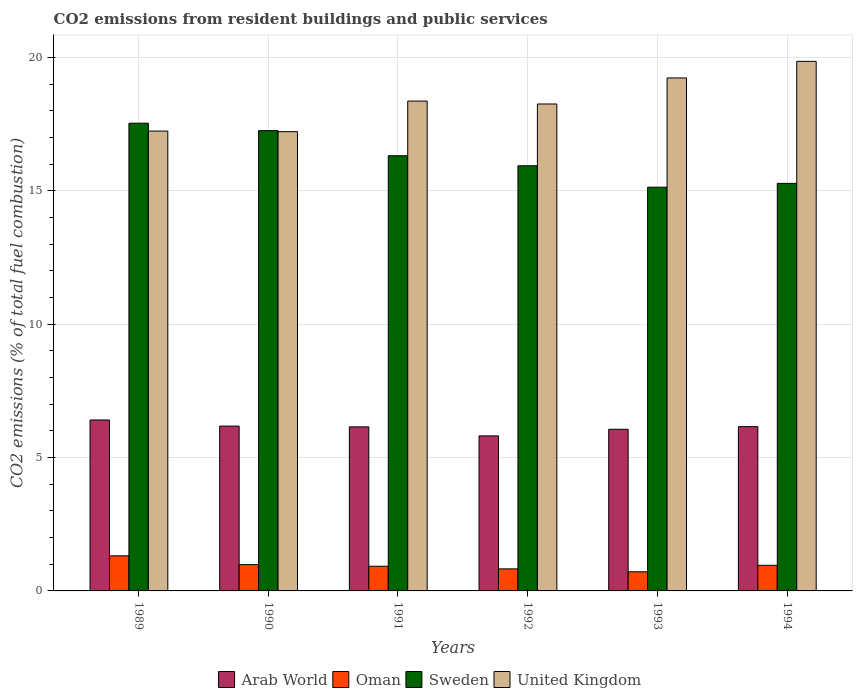Are the number of bars on each tick of the X-axis equal?
Your answer should be very brief. Yes. How many bars are there on the 6th tick from the right?
Give a very brief answer. 4. In how many cases, is the number of bars for a given year not equal to the number of legend labels?
Your response must be concise. 0. What is the total CO2 emitted in Oman in 1989?
Ensure brevity in your answer.  1.32. Across all years, what is the maximum total CO2 emitted in Oman?
Your answer should be very brief. 1.32. Across all years, what is the minimum total CO2 emitted in United Kingdom?
Keep it short and to the point. 17.22. In which year was the total CO2 emitted in Oman maximum?
Ensure brevity in your answer.  1989. What is the total total CO2 emitted in Arab World in the graph?
Your answer should be very brief. 36.77. What is the difference between the total CO2 emitted in Sweden in 1989 and that in 1994?
Make the answer very short. 2.26. What is the difference between the total CO2 emitted in United Kingdom in 1993 and the total CO2 emitted in Sweden in 1989?
Provide a succinct answer. 1.7. What is the average total CO2 emitted in Oman per year?
Your answer should be very brief. 0.96. In the year 1992, what is the difference between the total CO2 emitted in United Kingdom and total CO2 emitted in Oman?
Provide a short and direct response. 17.43. What is the ratio of the total CO2 emitted in Sweden in 1991 to that in 1994?
Offer a terse response. 1.07. Is the total CO2 emitted in Sweden in 1990 less than that in 1992?
Your response must be concise. No. Is the difference between the total CO2 emitted in United Kingdom in 1989 and 1990 greater than the difference between the total CO2 emitted in Oman in 1989 and 1990?
Provide a succinct answer. No. What is the difference between the highest and the second highest total CO2 emitted in Sweden?
Your answer should be compact. 0.28. What is the difference between the highest and the lowest total CO2 emitted in Sweden?
Provide a short and direct response. 2.4. What does the 3rd bar from the left in 1991 represents?
Your response must be concise. Sweden. What does the 4th bar from the right in 1992 represents?
Keep it short and to the point. Arab World. How many years are there in the graph?
Your answer should be compact. 6. What is the difference between two consecutive major ticks on the Y-axis?
Provide a short and direct response. 5. Does the graph contain any zero values?
Provide a succinct answer. No. Does the graph contain grids?
Keep it short and to the point. Yes. Where does the legend appear in the graph?
Offer a very short reply. Bottom center. How many legend labels are there?
Keep it short and to the point. 4. How are the legend labels stacked?
Provide a succinct answer. Horizontal. What is the title of the graph?
Give a very brief answer. CO2 emissions from resident buildings and public services. What is the label or title of the Y-axis?
Offer a terse response. CO2 emissions (% of total fuel combustion). What is the CO2 emissions (% of total fuel combustion) of Arab World in 1989?
Offer a terse response. 6.41. What is the CO2 emissions (% of total fuel combustion) in Oman in 1989?
Offer a terse response. 1.32. What is the CO2 emissions (% of total fuel combustion) of Sweden in 1989?
Your answer should be very brief. 17.54. What is the CO2 emissions (% of total fuel combustion) in United Kingdom in 1989?
Keep it short and to the point. 17.24. What is the CO2 emissions (% of total fuel combustion) of Arab World in 1990?
Your answer should be very brief. 6.18. What is the CO2 emissions (% of total fuel combustion) in Oman in 1990?
Ensure brevity in your answer.  0.99. What is the CO2 emissions (% of total fuel combustion) in Sweden in 1990?
Offer a very short reply. 17.26. What is the CO2 emissions (% of total fuel combustion) in United Kingdom in 1990?
Give a very brief answer. 17.22. What is the CO2 emissions (% of total fuel combustion) of Arab World in 1991?
Offer a very short reply. 6.15. What is the CO2 emissions (% of total fuel combustion) in Oman in 1991?
Your response must be concise. 0.93. What is the CO2 emissions (% of total fuel combustion) in Sweden in 1991?
Your answer should be very brief. 16.32. What is the CO2 emissions (% of total fuel combustion) of United Kingdom in 1991?
Ensure brevity in your answer.  18.36. What is the CO2 emissions (% of total fuel combustion) of Arab World in 1992?
Ensure brevity in your answer.  5.81. What is the CO2 emissions (% of total fuel combustion) in Oman in 1992?
Ensure brevity in your answer.  0.83. What is the CO2 emissions (% of total fuel combustion) in Sweden in 1992?
Offer a very short reply. 15.94. What is the CO2 emissions (% of total fuel combustion) of United Kingdom in 1992?
Provide a short and direct response. 18.26. What is the CO2 emissions (% of total fuel combustion) in Arab World in 1993?
Ensure brevity in your answer.  6.06. What is the CO2 emissions (% of total fuel combustion) of Oman in 1993?
Your response must be concise. 0.72. What is the CO2 emissions (% of total fuel combustion) in Sweden in 1993?
Offer a very short reply. 15.14. What is the CO2 emissions (% of total fuel combustion) in United Kingdom in 1993?
Keep it short and to the point. 19.23. What is the CO2 emissions (% of total fuel combustion) of Arab World in 1994?
Give a very brief answer. 6.16. What is the CO2 emissions (% of total fuel combustion) of Oman in 1994?
Provide a short and direct response. 0.96. What is the CO2 emissions (% of total fuel combustion) of Sweden in 1994?
Keep it short and to the point. 15.28. What is the CO2 emissions (% of total fuel combustion) in United Kingdom in 1994?
Provide a short and direct response. 19.85. Across all years, what is the maximum CO2 emissions (% of total fuel combustion) of Arab World?
Provide a succinct answer. 6.41. Across all years, what is the maximum CO2 emissions (% of total fuel combustion) in Oman?
Provide a short and direct response. 1.32. Across all years, what is the maximum CO2 emissions (% of total fuel combustion) of Sweden?
Ensure brevity in your answer.  17.54. Across all years, what is the maximum CO2 emissions (% of total fuel combustion) in United Kingdom?
Provide a short and direct response. 19.85. Across all years, what is the minimum CO2 emissions (% of total fuel combustion) in Arab World?
Make the answer very short. 5.81. Across all years, what is the minimum CO2 emissions (% of total fuel combustion) in Oman?
Your response must be concise. 0.72. Across all years, what is the minimum CO2 emissions (% of total fuel combustion) of Sweden?
Your answer should be very brief. 15.14. Across all years, what is the minimum CO2 emissions (% of total fuel combustion) of United Kingdom?
Offer a very short reply. 17.22. What is the total CO2 emissions (% of total fuel combustion) of Arab World in the graph?
Make the answer very short. 36.77. What is the total CO2 emissions (% of total fuel combustion) in Oman in the graph?
Provide a succinct answer. 5.73. What is the total CO2 emissions (% of total fuel combustion) of Sweden in the graph?
Keep it short and to the point. 97.46. What is the total CO2 emissions (% of total fuel combustion) in United Kingdom in the graph?
Give a very brief answer. 110.17. What is the difference between the CO2 emissions (% of total fuel combustion) of Arab World in 1989 and that in 1990?
Provide a short and direct response. 0.23. What is the difference between the CO2 emissions (% of total fuel combustion) of Oman in 1989 and that in 1990?
Make the answer very short. 0.33. What is the difference between the CO2 emissions (% of total fuel combustion) of Sweden in 1989 and that in 1990?
Keep it short and to the point. 0.28. What is the difference between the CO2 emissions (% of total fuel combustion) of United Kingdom in 1989 and that in 1990?
Ensure brevity in your answer.  0.02. What is the difference between the CO2 emissions (% of total fuel combustion) of Arab World in 1989 and that in 1991?
Your answer should be compact. 0.26. What is the difference between the CO2 emissions (% of total fuel combustion) in Oman in 1989 and that in 1991?
Give a very brief answer. 0.39. What is the difference between the CO2 emissions (% of total fuel combustion) of Sweden in 1989 and that in 1991?
Keep it short and to the point. 1.22. What is the difference between the CO2 emissions (% of total fuel combustion) in United Kingdom in 1989 and that in 1991?
Give a very brief answer. -1.12. What is the difference between the CO2 emissions (% of total fuel combustion) in Arab World in 1989 and that in 1992?
Your response must be concise. 0.6. What is the difference between the CO2 emissions (% of total fuel combustion) of Oman in 1989 and that in 1992?
Keep it short and to the point. 0.49. What is the difference between the CO2 emissions (% of total fuel combustion) of Sweden in 1989 and that in 1992?
Provide a short and direct response. 1.6. What is the difference between the CO2 emissions (% of total fuel combustion) of United Kingdom in 1989 and that in 1992?
Offer a very short reply. -1.02. What is the difference between the CO2 emissions (% of total fuel combustion) of Arab World in 1989 and that in 1993?
Provide a short and direct response. 0.35. What is the difference between the CO2 emissions (% of total fuel combustion) in Oman in 1989 and that in 1993?
Offer a terse response. 0.6. What is the difference between the CO2 emissions (% of total fuel combustion) in Sweden in 1989 and that in 1993?
Provide a short and direct response. 2.4. What is the difference between the CO2 emissions (% of total fuel combustion) of United Kingdom in 1989 and that in 1993?
Offer a terse response. -1.99. What is the difference between the CO2 emissions (% of total fuel combustion) in Arab World in 1989 and that in 1994?
Ensure brevity in your answer.  0.25. What is the difference between the CO2 emissions (% of total fuel combustion) of Oman in 1989 and that in 1994?
Your answer should be very brief. 0.35. What is the difference between the CO2 emissions (% of total fuel combustion) in Sweden in 1989 and that in 1994?
Keep it short and to the point. 2.26. What is the difference between the CO2 emissions (% of total fuel combustion) in United Kingdom in 1989 and that in 1994?
Offer a very short reply. -2.61. What is the difference between the CO2 emissions (% of total fuel combustion) of Arab World in 1990 and that in 1991?
Your response must be concise. 0.03. What is the difference between the CO2 emissions (% of total fuel combustion) of Oman in 1990 and that in 1991?
Your answer should be very brief. 0.06. What is the difference between the CO2 emissions (% of total fuel combustion) in Sweden in 1990 and that in 1991?
Make the answer very short. 0.94. What is the difference between the CO2 emissions (% of total fuel combustion) of United Kingdom in 1990 and that in 1991?
Your answer should be very brief. -1.15. What is the difference between the CO2 emissions (% of total fuel combustion) of Arab World in 1990 and that in 1992?
Your response must be concise. 0.37. What is the difference between the CO2 emissions (% of total fuel combustion) in Oman in 1990 and that in 1992?
Make the answer very short. 0.16. What is the difference between the CO2 emissions (% of total fuel combustion) in Sweden in 1990 and that in 1992?
Your answer should be very brief. 1.32. What is the difference between the CO2 emissions (% of total fuel combustion) of United Kingdom in 1990 and that in 1992?
Offer a terse response. -1.04. What is the difference between the CO2 emissions (% of total fuel combustion) in Arab World in 1990 and that in 1993?
Your answer should be compact. 0.12. What is the difference between the CO2 emissions (% of total fuel combustion) of Oman in 1990 and that in 1993?
Offer a terse response. 0.27. What is the difference between the CO2 emissions (% of total fuel combustion) in Sweden in 1990 and that in 1993?
Your answer should be very brief. 2.12. What is the difference between the CO2 emissions (% of total fuel combustion) of United Kingdom in 1990 and that in 1993?
Your answer should be very brief. -2.01. What is the difference between the CO2 emissions (% of total fuel combustion) of Arab World in 1990 and that in 1994?
Make the answer very short. 0.02. What is the difference between the CO2 emissions (% of total fuel combustion) in Oman in 1990 and that in 1994?
Your answer should be compact. 0.03. What is the difference between the CO2 emissions (% of total fuel combustion) of Sweden in 1990 and that in 1994?
Ensure brevity in your answer.  1.98. What is the difference between the CO2 emissions (% of total fuel combustion) in United Kingdom in 1990 and that in 1994?
Give a very brief answer. -2.64. What is the difference between the CO2 emissions (% of total fuel combustion) in Arab World in 1991 and that in 1992?
Your response must be concise. 0.34. What is the difference between the CO2 emissions (% of total fuel combustion) of Oman in 1991 and that in 1992?
Give a very brief answer. 0.1. What is the difference between the CO2 emissions (% of total fuel combustion) in Sweden in 1991 and that in 1992?
Offer a terse response. 0.38. What is the difference between the CO2 emissions (% of total fuel combustion) of United Kingdom in 1991 and that in 1992?
Offer a terse response. 0.11. What is the difference between the CO2 emissions (% of total fuel combustion) in Arab World in 1991 and that in 1993?
Your response must be concise. 0.09. What is the difference between the CO2 emissions (% of total fuel combustion) of Oman in 1991 and that in 1993?
Offer a terse response. 0.21. What is the difference between the CO2 emissions (% of total fuel combustion) of Sweden in 1991 and that in 1993?
Keep it short and to the point. 1.18. What is the difference between the CO2 emissions (% of total fuel combustion) of United Kingdom in 1991 and that in 1993?
Make the answer very short. -0.87. What is the difference between the CO2 emissions (% of total fuel combustion) in Arab World in 1991 and that in 1994?
Ensure brevity in your answer.  -0.01. What is the difference between the CO2 emissions (% of total fuel combustion) in Oman in 1991 and that in 1994?
Offer a very short reply. -0.04. What is the difference between the CO2 emissions (% of total fuel combustion) in Sweden in 1991 and that in 1994?
Your answer should be compact. 1.04. What is the difference between the CO2 emissions (% of total fuel combustion) in United Kingdom in 1991 and that in 1994?
Offer a very short reply. -1.49. What is the difference between the CO2 emissions (% of total fuel combustion) of Arab World in 1992 and that in 1993?
Your response must be concise. -0.25. What is the difference between the CO2 emissions (% of total fuel combustion) in Oman in 1992 and that in 1993?
Give a very brief answer. 0.11. What is the difference between the CO2 emissions (% of total fuel combustion) of Sweden in 1992 and that in 1993?
Keep it short and to the point. 0.8. What is the difference between the CO2 emissions (% of total fuel combustion) in United Kingdom in 1992 and that in 1993?
Provide a succinct answer. -0.98. What is the difference between the CO2 emissions (% of total fuel combustion) in Arab World in 1992 and that in 1994?
Make the answer very short. -0.35. What is the difference between the CO2 emissions (% of total fuel combustion) of Oman in 1992 and that in 1994?
Make the answer very short. -0.13. What is the difference between the CO2 emissions (% of total fuel combustion) in Sweden in 1992 and that in 1994?
Make the answer very short. 0.66. What is the difference between the CO2 emissions (% of total fuel combustion) in United Kingdom in 1992 and that in 1994?
Provide a short and direct response. -1.6. What is the difference between the CO2 emissions (% of total fuel combustion) of Arab World in 1993 and that in 1994?
Keep it short and to the point. -0.1. What is the difference between the CO2 emissions (% of total fuel combustion) in Oman in 1993 and that in 1994?
Keep it short and to the point. -0.24. What is the difference between the CO2 emissions (% of total fuel combustion) of Sweden in 1993 and that in 1994?
Your response must be concise. -0.14. What is the difference between the CO2 emissions (% of total fuel combustion) in United Kingdom in 1993 and that in 1994?
Provide a short and direct response. -0.62. What is the difference between the CO2 emissions (% of total fuel combustion) of Arab World in 1989 and the CO2 emissions (% of total fuel combustion) of Oman in 1990?
Your response must be concise. 5.42. What is the difference between the CO2 emissions (% of total fuel combustion) in Arab World in 1989 and the CO2 emissions (% of total fuel combustion) in Sweden in 1990?
Provide a succinct answer. -10.85. What is the difference between the CO2 emissions (% of total fuel combustion) of Arab World in 1989 and the CO2 emissions (% of total fuel combustion) of United Kingdom in 1990?
Offer a very short reply. -10.81. What is the difference between the CO2 emissions (% of total fuel combustion) of Oman in 1989 and the CO2 emissions (% of total fuel combustion) of Sweden in 1990?
Offer a very short reply. -15.94. What is the difference between the CO2 emissions (% of total fuel combustion) in Oman in 1989 and the CO2 emissions (% of total fuel combustion) in United Kingdom in 1990?
Make the answer very short. -15.9. What is the difference between the CO2 emissions (% of total fuel combustion) of Sweden in 1989 and the CO2 emissions (% of total fuel combustion) of United Kingdom in 1990?
Your answer should be very brief. 0.32. What is the difference between the CO2 emissions (% of total fuel combustion) of Arab World in 1989 and the CO2 emissions (% of total fuel combustion) of Oman in 1991?
Offer a very short reply. 5.48. What is the difference between the CO2 emissions (% of total fuel combustion) of Arab World in 1989 and the CO2 emissions (% of total fuel combustion) of Sweden in 1991?
Your answer should be compact. -9.91. What is the difference between the CO2 emissions (% of total fuel combustion) of Arab World in 1989 and the CO2 emissions (% of total fuel combustion) of United Kingdom in 1991?
Give a very brief answer. -11.96. What is the difference between the CO2 emissions (% of total fuel combustion) of Oman in 1989 and the CO2 emissions (% of total fuel combustion) of Sweden in 1991?
Your answer should be very brief. -15. What is the difference between the CO2 emissions (% of total fuel combustion) in Oman in 1989 and the CO2 emissions (% of total fuel combustion) in United Kingdom in 1991?
Provide a short and direct response. -17.05. What is the difference between the CO2 emissions (% of total fuel combustion) in Sweden in 1989 and the CO2 emissions (% of total fuel combustion) in United Kingdom in 1991?
Ensure brevity in your answer.  -0.83. What is the difference between the CO2 emissions (% of total fuel combustion) in Arab World in 1989 and the CO2 emissions (% of total fuel combustion) in Oman in 1992?
Offer a very short reply. 5.58. What is the difference between the CO2 emissions (% of total fuel combustion) of Arab World in 1989 and the CO2 emissions (% of total fuel combustion) of Sweden in 1992?
Keep it short and to the point. -9.53. What is the difference between the CO2 emissions (% of total fuel combustion) in Arab World in 1989 and the CO2 emissions (% of total fuel combustion) in United Kingdom in 1992?
Provide a short and direct response. -11.85. What is the difference between the CO2 emissions (% of total fuel combustion) of Oman in 1989 and the CO2 emissions (% of total fuel combustion) of Sweden in 1992?
Your answer should be compact. -14.62. What is the difference between the CO2 emissions (% of total fuel combustion) in Oman in 1989 and the CO2 emissions (% of total fuel combustion) in United Kingdom in 1992?
Offer a very short reply. -16.94. What is the difference between the CO2 emissions (% of total fuel combustion) of Sweden in 1989 and the CO2 emissions (% of total fuel combustion) of United Kingdom in 1992?
Provide a short and direct response. -0.72. What is the difference between the CO2 emissions (% of total fuel combustion) of Arab World in 1989 and the CO2 emissions (% of total fuel combustion) of Oman in 1993?
Offer a terse response. 5.69. What is the difference between the CO2 emissions (% of total fuel combustion) of Arab World in 1989 and the CO2 emissions (% of total fuel combustion) of Sweden in 1993?
Your response must be concise. -8.73. What is the difference between the CO2 emissions (% of total fuel combustion) in Arab World in 1989 and the CO2 emissions (% of total fuel combustion) in United Kingdom in 1993?
Provide a succinct answer. -12.82. What is the difference between the CO2 emissions (% of total fuel combustion) in Oman in 1989 and the CO2 emissions (% of total fuel combustion) in Sweden in 1993?
Give a very brief answer. -13.82. What is the difference between the CO2 emissions (% of total fuel combustion) in Oman in 1989 and the CO2 emissions (% of total fuel combustion) in United Kingdom in 1993?
Offer a terse response. -17.92. What is the difference between the CO2 emissions (% of total fuel combustion) of Sweden in 1989 and the CO2 emissions (% of total fuel combustion) of United Kingdom in 1993?
Provide a succinct answer. -1.7. What is the difference between the CO2 emissions (% of total fuel combustion) in Arab World in 1989 and the CO2 emissions (% of total fuel combustion) in Oman in 1994?
Your answer should be very brief. 5.45. What is the difference between the CO2 emissions (% of total fuel combustion) in Arab World in 1989 and the CO2 emissions (% of total fuel combustion) in Sweden in 1994?
Your answer should be compact. -8.87. What is the difference between the CO2 emissions (% of total fuel combustion) in Arab World in 1989 and the CO2 emissions (% of total fuel combustion) in United Kingdom in 1994?
Your answer should be compact. -13.45. What is the difference between the CO2 emissions (% of total fuel combustion) of Oman in 1989 and the CO2 emissions (% of total fuel combustion) of Sweden in 1994?
Make the answer very short. -13.96. What is the difference between the CO2 emissions (% of total fuel combustion) of Oman in 1989 and the CO2 emissions (% of total fuel combustion) of United Kingdom in 1994?
Make the answer very short. -18.54. What is the difference between the CO2 emissions (% of total fuel combustion) of Sweden in 1989 and the CO2 emissions (% of total fuel combustion) of United Kingdom in 1994?
Your response must be concise. -2.32. What is the difference between the CO2 emissions (% of total fuel combustion) in Arab World in 1990 and the CO2 emissions (% of total fuel combustion) in Oman in 1991?
Ensure brevity in your answer.  5.25. What is the difference between the CO2 emissions (% of total fuel combustion) of Arab World in 1990 and the CO2 emissions (% of total fuel combustion) of Sweden in 1991?
Your answer should be compact. -10.14. What is the difference between the CO2 emissions (% of total fuel combustion) of Arab World in 1990 and the CO2 emissions (% of total fuel combustion) of United Kingdom in 1991?
Provide a short and direct response. -12.19. What is the difference between the CO2 emissions (% of total fuel combustion) in Oman in 1990 and the CO2 emissions (% of total fuel combustion) in Sweden in 1991?
Provide a short and direct response. -15.33. What is the difference between the CO2 emissions (% of total fuel combustion) in Oman in 1990 and the CO2 emissions (% of total fuel combustion) in United Kingdom in 1991?
Your answer should be very brief. -17.38. What is the difference between the CO2 emissions (% of total fuel combustion) in Sweden in 1990 and the CO2 emissions (% of total fuel combustion) in United Kingdom in 1991?
Provide a succinct answer. -1.11. What is the difference between the CO2 emissions (% of total fuel combustion) of Arab World in 1990 and the CO2 emissions (% of total fuel combustion) of Oman in 1992?
Offer a terse response. 5.35. What is the difference between the CO2 emissions (% of total fuel combustion) in Arab World in 1990 and the CO2 emissions (% of total fuel combustion) in Sweden in 1992?
Make the answer very short. -9.76. What is the difference between the CO2 emissions (% of total fuel combustion) in Arab World in 1990 and the CO2 emissions (% of total fuel combustion) in United Kingdom in 1992?
Your answer should be very brief. -12.08. What is the difference between the CO2 emissions (% of total fuel combustion) of Oman in 1990 and the CO2 emissions (% of total fuel combustion) of Sweden in 1992?
Your response must be concise. -14.95. What is the difference between the CO2 emissions (% of total fuel combustion) in Oman in 1990 and the CO2 emissions (% of total fuel combustion) in United Kingdom in 1992?
Offer a terse response. -17.27. What is the difference between the CO2 emissions (% of total fuel combustion) of Sweden in 1990 and the CO2 emissions (% of total fuel combustion) of United Kingdom in 1992?
Make the answer very short. -1. What is the difference between the CO2 emissions (% of total fuel combustion) in Arab World in 1990 and the CO2 emissions (% of total fuel combustion) in Oman in 1993?
Provide a short and direct response. 5.46. What is the difference between the CO2 emissions (% of total fuel combustion) of Arab World in 1990 and the CO2 emissions (% of total fuel combustion) of Sweden in 1993?
Provide a short and direct response. -8.96. What is the difference between the CO2 emissions (% of total fuel combustion) of Arab World in 1990 and the CO2 emissions (% of total fuel combustion) of United Kingdom in 1993?
Ensure brevity in your answer.  -13.05. What is the difference between the CO2 emissions (% of total fuel combustion) in Oman in 1990 and the CO2 emissions (% of total fuel combustion) in Sweden in 1993?
Offer a terse response. -14.15. What is the difference between the CO2 emissions (% of total fuel combustion) in Oman in 1990 and the CO2 emissions (% of total fuel combustion) in United Kingdom in 1993?
Give a very brief answer. -18.25. What is the difference between the CO2 emissions (% of total fuel combustion) in Sweden in 1990 and the CO2 emissions (% of total fuel combustion) in United Kingdom in 1993?
Your response must be concise. -1.98. What is the difference between the CO2 emissions (% of total fuel combustion) of Arab World in 1990 and the CO2 emissions (% of total fuel combustion) of Oman in 1994?
Offer a very short reply. 5.22. What is the difference between the CO2 emissions (% of total fuel combustion) of Arab World in 1990 and the CO2 emissions (% of total fuel combustion) of Sweden in 1994?
Keep it short and to the point. -9.1. What is the difference between the CO2 emissions (% of total fuel combustion) of Arab World in 1990 and the CO2 emissions (% of total fuel combustion) of United Kingdom in 1994?
Your answer should be very brief. -13.68. What is the difference between the CO2 emissions (% of total fuel combustion) in Oman in 1990 and the CO2 emissions (% of total fuel combustion) in Sweden in 1994?
Give a very brief answer. -14.29. What is the difference between the CO2 emissions (% of total fuel combustion) of Oman in 1990 and the CO2 emissions (% of total fuel combustion) of United Kingdom in 1994?
Provide a short and direct response. -18.87. What is the difference between the CO2 emissions (% of total fuel combustion) of Sweden in 1990 and the CO2 emissions (% of total fuel combustion) of United Kingdom in 1994?
Keep it short and to the point. -2.6. What is the difference between the CO2 emissions (% of total fuel combustion) in Arab World in 1991 and the CO2 emissions (% of total fuel combustion) in Oman in 1992?
Make the answer very short. 5.32. What is the difference between the CO2 emissions (% of total fuel combustion) in Arab World in 1991 and the CO2 emissions (% of total fuel combustion) in Sweden in 1992?
Make the answer very short. -9.79. What is the difference between the CO2 emissions (% of total fuel combustion) in Arab World in 1991 and the CO2 emissions (% of total fuel combustion) in United Kingdom in 1992?
Provide a short and direct response. -12.11. What is the difference between the CO2 emissions (% of total fuel combustion) in Oman in 1991 and the CO2 emissions (% of total fuel combustion) in Sweden in 1992?
Provide a succinct answer. -15.01. What is the difference between the CO2 emissions (% of total fuel combustion) of Oman in 1991 and the CO2 emissions (% of total fuel combustion) of United Kingdom in 1992?
Give a very brief answer. -17.33. What is the difference between the CO2 emissions (% of total fuel combustion) of Sweden in 1991 and the CO2 emissions (% of total fuel combustion) of United Kingdom in 1992?
Give a very brief answer. -1.94. What is the difference between the CO2 emissions (% of total fuel combustion) in Arab World in 1991 and the CO2 emissions (% of total fuel combustion) in Oman in 1993?
Your answer should be very brief. 5.43. What is the difference between the CO2 emissions (% of total fuel combustion) of Arab World in 1991 and the CO2 emissions (% of total fuel combustion) of Sweden in 1993?
Offer a terse response. -8.99. What is the difference between the CO2 emissions (% of total fuel combustion) of Arab World in 1991 and the CO2 emissions (% of total fuel combustion) of United Kingdom in 1993?
Give a very brief answer. -13.08. What is the difference between the CO2 emissions (% of total fuel combustion) in Oman in 1991 and the CO2 emissions (% of total fuel combustion) in Sweden in 1993?
Make the answer very short. -14.21. What is the difference between the CO2 emissions (% of total fuel combustion) in Oman in 1991 and the CO2 emissions (% of total fuel combustion) in United Kingdom in 1993?
Provide a succinct answer. -18.31. What is the difference between the CO2 emissions (% of total fuel combustion) of Sweden in 1991 and the CO2 emissions (% of total fuel combustion) of United Kingdom in 1993?
Make the answer very short. -2.92. What is the difference between the CO2 emissions (% of total fuel combustion) of Arab World in 1991 and the CO2 emissions (% of total fuel combustion) of Oman in 1994?
Give a very brief answer. 5.19. What is the difference between the CO2 emissions (% of total fuel combustion) of Arab World in 1991 and the CO2 emissions (% of total fuel combustion) of Sweden in 1994?
Your answer should be very brief. -9.13. What is the difference between the CO2 emissions (% of total fuel combustion) in Arab World in 1991 and the CO2 emissions (% of total fuel combustion) in United Kingdom in 1994?
Your answer should be very brief. -13.7. What is the difference between the CO2 emissions (% of total fuel combustion) of Oman in 1991 and the CO2 emissions (% of total fuel combustion) of Sweden in 1994?
Provide a succinct answer. -14.35. What is the difference between the CO2 emissions (% of total fuel combustion) of Oman in 1991 and the CO2 emissions (% of total fuel combustion) of United Kingdom in 1994?
Give a very brief answer. -18.93. What is the difference between the CO2 emissions (% of total fuel combustion) of Sweden in 1991 and the CO2 emissions (% of total fuel combustion) of United Kingdom in 1994?
Ensure brevity in your answer.  -3.54. What is the difference between the CO2 emissions (% of total fuel combustion) in Arab World in 1992 and the CO2 emissions (% of total fuel combustion) in Oman in 1993?
Provide a succinct answer. 5.1. What is the difference between the CO2 emissions (% of total fuel combustion) of Arab World in 1992 and the CO2 emissions (% of total fuel combustion) of Sweden in 1993?
Give a very brief answer. -9.32. What is the difference between the CO2 emissions (% of total fuel combustion) in Arab World in 1992 and the CO2 emissions (% of total fuel combustion) in United Kingdom in 1993?
Offer a terse response. -13.42. What is the difference between the CO2 emissions (% of total fuel combustion) in Oman in 1992 and the CO2 emissions (% of total fuel combustion) in Sweden in 1993?
Provide a short and direct response. -14.31. What is the difference between the CO2 emissions (% of total fuel combustion) in Oman in 1992 and the CO2 emissions (% of total fuel combustion) in United Kingdom in 1993?
Offer a terse response. -18.41. What is the difference between the CO2 emissions (% of total fuel combustion) in Sweden in 1992 and the CO2 emissions (% of total fuel combustion) in United Kingdom in 1993?
Give a very brief answer. -3.29. What is the difference between the CO2 emissions (% of total fuel combustion) of Arab World in 1992 and the CO2 emissions (% of total fuel combustion) of Oman in 1994?
Give a very brief answer. 4.85. What is the difference between the CO2 emissions (% of total fuel combustion) of Arab World in 1992 and the CO2 emissions (% of total fuel combustion) of Sweden in 1994?
Keep it short and to the point. -9.47. What is the difference between the CO2 emissions (% of total fuel combustion) of Arab World in 1992 and the CO2 emissions (% of total fuel combustion) of United Kingdom in 1994?
Make the answer very short. -14.04. What is the difference between the CO2 emissions (% of total fuel combustion) in Oman in 1992 and the CO2 emissions (% of total fuel combustion) in Sweden in 1994?
Your answer should be very brief. -14.45. What is the difference between the CO2 emissions (% of total fuel combustion) in Oman in 1992 and the CO2 emissions (% of total fuel combustion) in United Kingdom in 1994?
Your answer should be compact. -19.03. What is the difference between the CO2 emissions (% of total fuel combustion) of Sweden in 1992 and the CO2 emissions (% of total fuel combustion) of United Kingdom in 1994?
Offer a very short reply. -3.91. What is the difference between the CO2 emissions (% of total fuel combustion) of Arab World in 1993 and the CO2 emissions (% of total fuel combustion) of Oman in 1994?
Keep it short and to the point. 5.1. What is the difference between the CO2 emissions (% of total fuel combustion) in Arab World in 1993 and the CO2 emissions (% of total fuel combustion) in Sweden in 1994?
Give a very brief answer. -9.22. What is the difference between the CO2 emissions (% of total fuel combustion) in Arab World in 1993 and the CO2 emissions (% of total fuel combustion) in United Kingdom in 1994?
Keep it short and to the point. -13.79. What is the difference between the CO2 emissions (% of total fuel combustion) of Oman in 1993 and the CO2 emissions (% of total fuel combustion) of Sweden in 1994?
Ensure brevity in your answer.  -14.56. What is the difference between the CO2 emissions (% of total fuel combustion) of Oman in 1993 and the CO2 emissions (% of total fuel combustion) of United Kingdom in 1994?
Your answer should be compact. -19.14. What is the difference between the CO2 emissions (% of total fuel combustion) of Sweden in 1993 and the CO2 emissions (% of total fuel combustion) of United Kingdom in 1994?
Make the answer very short. -4.72. What is the average CO2 emissions (% of total fuel combustion) of Arab World per year?
Give a very brief answer. 6.13. What is the average CO2 emissions (% of total fuel combustion) in Oman per year?
Offer a very short reply. 0.96. What is the average CO2 emissions (% of total fuel combustion) of Sweden per year?
Keep it short and to the point. 16.24. What is the average CO2 emissions (% of total fuel combustion) of United Kingdom per year?
Your answer should be compact. 18.36. In the year 1989, what is the difference between the CO2 emissions (% of total fuel combustion) of Arab World and CO2 emissions (% of total fuel combustion) of Oman?
Your answer should be very brief. 5.09. In the year 1989, what is the difference between the CO2 emissions (% of total fuel combustion) of Arab World and CO2 emissions (% of total fuel combustion) of Sweden?
Ensure brevity in your answer.  -11.13. In the year 1989, what is the difference between the CO2 emissions (% of total fuel combustion) of Arab World and CO2 emissions (% of total fuel combustion) of United Kingdom?
Your answer should be very brief. -10.83. In the year 1989, what is the difference between the CO2 emissions (% of total fuel combustion) of Oman and CO2 emissions (% of total fuel combustion) of Sweden?
Ensure brevity in your answer.  -16.22. In the year 1989, what is the difference between the CO2 emissions (% of total fuel combustion) in Oman and CO2 emissions (% of total fuel combustion) in United Kingdom?
Your answer should be compact. -15.92. In the year 1989, what is the difference between the CO2 emissions (% of total fuel combustion) in Sweden and CO2 emissions (% of total fuel combustion) in United Kingdom?
Ensure brevity in your answer.  0.3. In the year 1990, what is the difference between the CO2 emissions (% of total fuel combustion) of Arab World and CO2 emissions (% of total fuel combustion) of Oman?
Make the answer very short. 5.19. In the year 1990, what is the difference between the CO2 emissions (% of total fuel combustion) in Arab World and CO2 emissions (% of total fuel combustion) in Sweden?
Your response must be concise. -11.08. In the year 1990, what is the difference between the CO2 emissions (% of total fuel combustion) of Arab World and CO2 emissions (% of total fuel combustion) of United Kingdom?
Provide a short and direct response. -11.04. In the year 1990, what is the difference between the CO2 emissions (% of total fuel combustion) in Oman and CO2 emissions (% of total fuel combustion) in Sweden?
Keep it short and to the point. -16.27. In the year 1990, what is the difference between the CO2 emissions (% of total fuel combustion) in Oman and CO2 emissions (% of total fuel combustion) in United Kingdom?
Keep it short and to the point. -16.23. In the year 1990, what is the difference between the CO2 emissions (% of total fuel combustion) in Sweden and CO2 emissions (% of total fuel combustion) in United Kingdom?
Provide a succinct answer. 0.04. In the year 1991, what is the difference between the CO2 emissions (% of total fuel combustion) in Arab World and CO2 emissions (% of total fuel combustion) in Oman?
Keep it short and to the point. 5.23. In the year 1991, what is the difference between the CO2 emissions (% of total fuel combustion) in Arab World and CO2 emissions (% of total fuel combustion) in Sweden?
Offer a terse response. -10.16. In the year 1991, what is the difference between the CO2 emissions (% of total fuel combustion) in Arab World and CO2 emissions (% of total fuel combustion) in United Kingdom?
Your answer should be compact. -12.21. In the year 1991, what is the difference between the CO2 emissions (% of total fuel combustion) in Oman and CO2 emissions (% of total fuel combustion) in Sweden?
Ensure brevity in your answer.  -15.39. In the year 1991, what is the difference between the CO2 emissions (% of total fuel combustion) in Oman and CO2 emissions (% of total fuel combustion) in United Kingdom?
Provide a short and direct response. -17.44. In the year 1991, what is the difference between the CO2 emissions (% of total fuel combustion) of Sweden and CO2 emissions (% of total fuel combustion) of United Kingdom?
Provide a short and direct response. -2.05. In the year 1992, what is the difference between the CO2 emissions (% of total fuel combustion) of Arab World and CO2 emissions (% of total fuel combustion) of Oman?
Your answer should be compact. 4.99. In the year 1992, what is the difference between the CO2 emissions (% of total fuel combustion) in Arab World and CO2 emissions (% of total fuel combustion) in Sweden?
Your answer should be very brief. -10.13. In the year 1992, what is the difference between the CO2 emissions (% of total fuel combustion) in Arab World and CO2 emissions (% of total fuel combustion) in United Kingdom?
Keep it short and to the point. -12.44. In the year 1992, what is the difference between the CO2 emissions (% of total fuel combustion) in Oman and CO2 emissions (% of total fuel combustion) in Sweden?
Keep it short and to the point. -15.11. In the year 1992, what is the difference between the CO2 emissions (% of total fuel combustion) of Oman and CO2 emissions (% of total fuel combustion) of United Kingdom?
Provide a short and direct response. -17.43. In the year 1992, what is the difference between the CO2 emissions (% of total fuel combustion) in Sweden and CO2 emissions (% of total fuel combustion) in United Kingdom?
Your answer should be very brief. -2.32. In the year 1993, what is the difference between the CO2 emissions (% of total fuel combustion) in Arab World and CO2 emissions (% of total fuel combustion) in Oman?
Provide a short and direct response. 5.34. In the year 1993, what is the difference between the CO2 emissions (% of total fuel combustion) of Arab World and CO2 emissions (% of total fuel combustion) of Sweden?
Keep it short and to the point. -9.08. In the year 1993, what is the difference between the CO2 emissions (% of total fuel combustion) in Arab World and CO2 emissions (% of total fuel combustion) in United Kingdom?
Provide a succinct answer. -13.17. In the year 1993, what is the difference between the CO2 emissions (% of total fuel combustion) of Oman and CO2 emissions (% of total fuel combustion) of Sweden?
Make the answer very short. -14.42. In the year 1993, what is the difference between the CO2 emissions (% of total fuel combustion) in Oman and CO2 emissions (% of total fuel combustion) in United Kingdom?
Make the answer very short. -18.51. In the year 1993, what is the difference between the CO2 emissions (% of total fuel combustion) of Sweden and CO2 emissions (% of total fuel combustion) of United Kingdom?
Make the answer very short. -4.1. In the year 1994, what is the difference between the CO2 emissions (% of total fuel combustion) in Arab World and CO2 emissions (% of total fuel combustion) in Oman?
Offer a very short reply. 5.2. In the year 1994, what is the difference between the CO2 emissions (% of total fuel combustion) of Arab World and CO2 emissions (% of total fuel combustion) of Sweden?
Provide a short and direct response. -9.12. In the year 1994, what is the difference between the CO2 emissions (% of total fuel combustion) of Arab World and CO2 emissions (% of total fuel combustion) of United Kingdom?
Provide a succinct answer. -13.69. In the year 1994, what is the difference between the CO2 emissions (% of total fuel combustion) in Oman and CO2 emissions (% of total fuel combustion) in Sweden?
Your answer should be compact. -14.32. In the year 1994, what is the difference between the CO2 emissions (% of total fuel combustion) in Oman and CO2 emissions (% of total fuel combustion) in United Kingdom?
Keep it short and to the point. -18.89. In the year 1994, what is the difference between the CO2 emissions (% of total fuel combustion) of Sweden and CO2 emissions (% of total fuel combustion) of United Kingdom?
Give a very brief answer. -4.57. What is the ratio of the CO2 emissions (% of total fuel combustion) in Arab World in 1989 to that in 1990?
Your response must be concise. 1.04. What is the ratio of the CO2 emissions (% of total fuel combustion) in Oman in 1989 to that in 1990?
Your answer should be very brief. 1.33. What is the ratio of the CO2 emissions (% of total fuel combustion) in Sweden in 1989 to that in 1990?
Your answer should be compact. 1.02. What is the ratio of the CO2 emissions (% of total fuel combustion) in United Kingdom in 1989 to that in 1990?
Your response must be concise. 1. What is the ratio of the CO2 emissions (% of total fuel combustion) in Arab World in 1989 to that in 1991?
Provide a short and direct response. 1.04. What is the ratio of the CO2 emissions (% of total fuel combustion) of Oman in 1989 to that in 1991?
Keep it short and to the point. 1.42. What is the ratio of the CO2 emissions (% of total fuel combustion) in Sweden in 1989 to that in 1991?
Offer a very short reply. 1.07. What is the ratio of the CO2 emissions (% of total fuel combustion) of United Kingdom in 1989 to that in 1991?
Keep it short and to the point. 0.94. What is the ratio of the CO2 emissions (% of total fuel combustion) in Arab World in 1989 to that in 1992?
Give a very brief answer. 1.1. What is the ratio of the CO2 emissions (% of total fuel combustion) of Oman in 1989 to that in 1992?
Offer a terse response. 1.59. What is the ratio of the CO2 emissions (% of total fuel combustion) of Sweden in 1989 to that in 1992?
Your answer should be compact. 1.1. What is the ratio of the CO2 emissions (% of total fuel combustion) of Arab World in 1989 to that in 1993?
Keep it short and to the point. 1.06. What is the ratio of the CO2 emissions (% of total fuel combustion) in Oman in 1989 to that in 1993?
Make the answer very short. 1.83. What is the ratio of the CO2 emissions (% of total fuel combustion) of Sweden in 1989 to that in 1993?
Provide a succinct answer. 1.16. What is the ratio of the CO2 emissions (% of total fuel combustion) of United Kingdom in 1989 to that in 1993?
Your answer should be very brief. 0.9. What is the ratio of the CO2 emissions (% of total fuel combustion) in Arab World in 1989 to that in 1994?
Offer a very short reply. 1.04. What is the ratio of the CO2 emissions (% of total fuel combustion) of Oman in 1989 to that in 1994?
Offer a very short reply. 1.37. What is the ratio of the CO2 emissions (% of total fuel combustion) of Sweden in 1989 to that in 1994?
Keep it short and to the point. 1.15. What is the ratio of the CO2 emissions (% of total fuel combustion) of United Kingdom in 1989 to that in 1994?
Your answer should be compact. 0.87. What is the ratio of the CO2 emissions (% of total fuel combustion) in Oman in 1990 to that in 1991?
Your response must be concise. 1.07. What is the ratio of the CO2 emissions (% of total fuel combustion) in Sweden in 1990 to that in 1991?
Make the answer very short. 1.06. What is the ratio of the CO2 emissions (% of total fuel combustion) in United Kingdom in 1990 to that in 1991?
Provide a short and direct response. 0.94. What is the ratio of the CO2 emissions (% of total fuel combustion) of Arab World in 1990 to that in 1992?
Your answer should be very brief. 1.06. What is the ratio of the CO2 emissions (% of total fuel combustion) of Oman in 1990 to that in 1992?
Offer a very short reply. 1.19. What is the ratio of the CO2 emissions (% of total fuel combustion) in Sweden in 1990 to that in 1992?
Make the answer very short. 1.08. What is the ratio of the CO2 emissions (% of total fuel combustion) of United Kingdom in 1990 to that in 1992?
Give a very brief answer. 0.94. What is the ratio of the CO2 emissions (% of total fuel combustion) in Arab World in 1990 to that in 1993?
Offer a terse response. 1.02. What is the ratio of the CO2 emissions (% of total fuel combustion) of Oman in 1990 to that in 1993?
Offer a terse response. 1.38. What is the ratio of the CO2 emissions (% of total fuel combustion) of Sweden in 1990 to that in 1993?
Your answer should be very brief. 1.14. What is the ratio of the CO2 emissions (% of total fuel combustion) of United Kingdom in 1990 to that in 1993?
Your response must be concise. 0.9. What is the ratio of the CO2 emissions (% of total fuel combustion) of Oman in 1990 to that in 1994?
Provide a succinct answer. 1.03. What is the ratio of the CO2 emissions (% of total fuel combustion) in Sweden in 1990 to that in 1994?
Make the answer very short. 1.13. What is the ratio of the CO2 emissions (% of total fuel combustion) of United Kingdom in 1990 to that in 1994?
Keep it short and to the point. 0.87. What is the ratio of the CO2 emissions (% of total fuel combustion) in Arab World in 1991 to that in 1992?
Make the answer very short. 1.06. What is the ratio of the CO2 emissions (% of total fuel combustion) of Oman in 1991 to that in 1992?
Make the answer very short. 1.12. What is the ratio of the CO2 emissions (% of total fuel combustion) in Sweden in 1991 to that in 1992?
Your answer should be very brief. 1.02. What is the ratio of the CO2 emissions (% of total fuel combustion) in United Kingdom in 1991 to that in 1992?
Your response must be concise. 1.01. What is the ratio of the CO2 emissions (% of total fuel combustion) in Arab World in 1991 to that in 1993?
Your answer should be compact. 1.01. What is the ratio of the CO2 emissions (% of total fuel combustion) of Oman in 1991 to that in 1993?
Your response must be concise. 1.29. What is the ratio of the CO2 emissions (% of total fuel combustion) of Sweden in 1991 to that in 1993?
Ensure brevity in your answer.  1.08. What is the ratio of the CO2 emissions (% of total fuel combustion) of United Kingdom in 1991 to that in 1993?
Offer a terse response. 0.95. What is the ratio of the CO2 emissions (% of total fuel combustion) of Arab World in 1991 to that in 1994?
Give a very brief answer. 1. What is the ratio of the CO2 emissions (% of total fuel combustion) in Sweden in 1991 to that in 1994?
Give a very brief answer. 1.07. What is the ratio of the CO2 emissions (% of total fuel combustion) of United Kingdom in 1991 to that in 1994?
Keep it short and to the point. 0.93. What is the ratio of the CO2 emissions (% of total fuel combustion) in Arab World in 1992 to that in 1993?
Offer a terse response. 0.96. What is the ratio of the CO2 emissions (% of total fuel combustion) in Oman in 1992 to that in 1993?
Provide a short and direct response. 1.15. What is the ratio of the CO2 emissions (% of total fuel combustion) in Sweden in 1992 to that in 1993?
Provide a short and direct response. 1.05. What is the ratio of the CO2 emissions (% of total fuel combustion) in United Kingdom in 1992 to that in 1993?
Make the answer very short. 0.95. What is the ratio of the CO2 emissions (% of total fuel combustion) in Arab World in 1992 to that in 1994?
Keep it short and to the point. 0.94. What is the ratio of the CO2 emissions (% of total fuel combustion) in Oman in 1992 to that in 1994?
Offer a terse response. 0.86. What is the ratio of the CO2 emissions (% of total fuel combustion) of Sweden in 1992 to that in 1994?
Offer a very short reply. 1.04. What is the ratio of the CO2 emissions (% of total fuel combustion) of United Kingdom in 1992 to that in 1994?
Your answer should be compact. 0.92. What is the ratio of the CO2 emissions (% of total fuel combustion) of Arab World in 1993 to that in 1994?
Offer a terse response. 0.98. What is the ratio of the CO2 emissions (% of total fuel combustion) of Oman in 1993 to that in 1994?
Provide a succinct answer. 0.75. What is the ratio of the CO2 emissions (% of total fuel combustion) in Sweden in 1993 to that in 1994?
Give a very brief answer. 0.99. What is the ratio of the CO2 emissions (% of total fuel combustion) of United Kingdom in 1993 to that in 1994?
Offer a terse response. 0.97. What is the difference between the highest and the second highest CO2 emissions (% of total fuel combustion) of Arab World?
Ensure brevity in your answer.  0.23. What is the difference between the highest and the second highest CO2 emissions (% of total fuel combustion) of Oman?
Make the answer very short. 0.33. What is the difference between the highest and the second highest CO2 emissions (% of total fuel combustion) in Sweden?
Your answer should be very brief. 0.28. What is the difference between the highest and the second highest CO2 emissions (% of total fuel combustion) in United Kingdom?
Keep it short and to the point. 0.62. What is the difference between the highest and the lowest CO2 emissions (% of total fuel combustion) in Arab World?
Offer a terse response. 0.6. What is the difference between the highest and the lowest CO2 emissions (% of total fuel combustion) of Oman?
Your response must be concise. 0.6. What is the difference between the highest and the lowest CO2 emissions (% of total fuel combustion) of Sweden?
Keep it short and to the point. 2.4. What is the difference between the highest and the lowest CO2 emissions (% of total fuel combustion) of United Kingdom?
Your response must be concise. 2.64. 